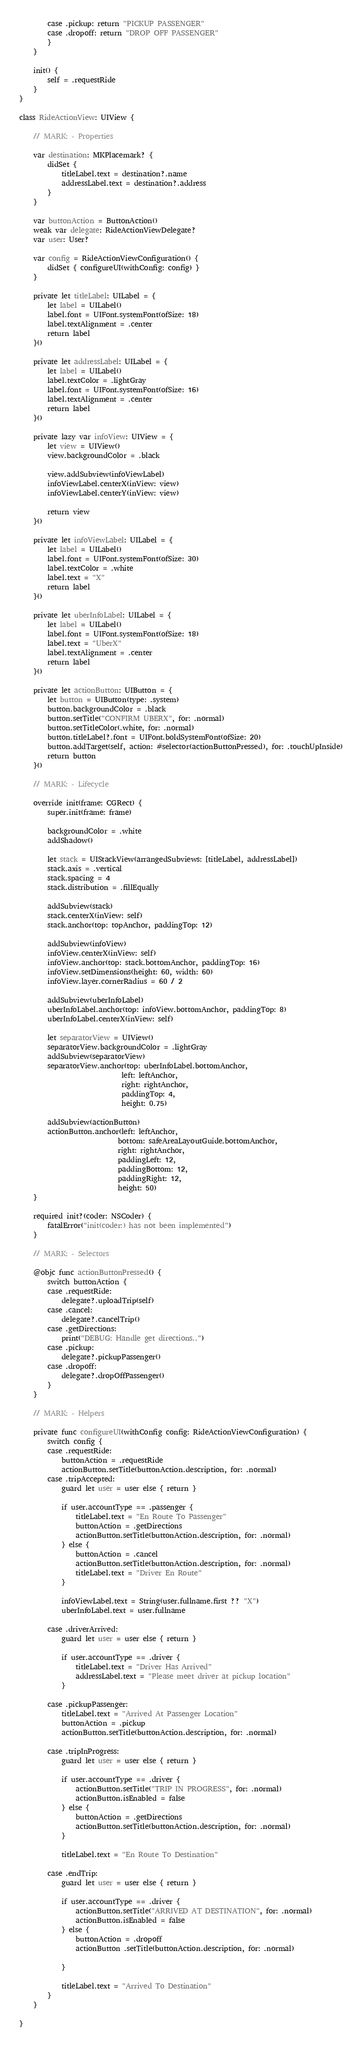<code> <loc_0><loc_0><loc_500><loc_500><_Swift_>        case .pickup: return "PICKUP PASSENGER"
        case .dropoff: return "DROP OFF PASSENGER"
        }
    }
    
    init() {
        self = .requestRide
    }
}

class RideActionView: UIView {

    // MARK: - Properties
    
    var destination: MKPlacemark? {
        didSet {
            titleLabel.text = destination?.name
            addressLabel.text = destination?.address
        }
    }
    
    var buttonAction = ButtonAction()
    weak var delegate: RideActionViewDelegate?
    var user: User?
    
    var config = RideActionViewConfiguration() {
        didSet { configureUI(withConfig: config) }
    }
    
    private let titleLabel: UILabel = {
        let label = UILabel()
        label.font = UIFont.systemFont(ofSize: 18)
        label.textAlignment = .center
        return label
    }()
    
    private let addressLabel: UILabel = {
        let label = UILabel()
        label.textColor = .lightGray
        label.font = UIFont.systemFont(ofSize: 16)
        label.textAlignment = .center
        return label
    }()
    
    private lazy var infoView: UIView = {
        let view = UIView()
        view.backgroundColor = .black
        
        view.addSubview(infoViewLabel)
        infoViewLabel.centerX(inView: view)
        infoViewLabel.centerY(inView: view)
        
        return view
    }()
    
    private let infoViewLabel: UILabel = {
        let label = UILabel()
        label.font = UIFont.systemFont(ofSize: 30)
        label.textColor = .white
        label.text = "X"
        return label
    }()
    
    private let uberInfoLabel: UILabel = {
        let label = UILabel()
        label.font = UIFont.systemFont(ofSize: 18)
        label.text = "UberX"
        label.textAlignment = .center
        return label
    }()
    
    private let actionButton: UIButton = {
        let button = UIButton(type: .system)
        button.backgroundColor = .black
        button.setTitle("CONFIRM UBERX", for: .normal)
        button.setTitleColor(.white, for: .normal)
        button.titleLabel?.font = UIFont.boldSystemFont(ofSize: 20)
        button.addTarget(self, action: #selector(actionButtonPressed), for: .touchUpInside)
        return button
    }()
    
    // MARK: - Lifecycle
    
    override init(frame: CGRect) {
        super.init(frame: frame)
        
        backgroundColor = .white
        addShadow()
    
        let stack = UIStackView(arrangedSubviews: [titleLabel, addressLabel])
        stack.axis = .vertical
        stack.spacing = 4
        stack.distribution = .fillEqually
        
        addSubview(stack)
        stack.centerX(inView: self)
        stack.anchor(top: topAnchor, paddingTop: 12)
        
        addSubview(infoView)
        infoView.centerX(inView: self)
        infoView.anchor(top: stack.bottomAnchor, paddingTop: 16)
        infoView.setDimensions(height: 60, width: 60)
        infoView.layer.cornerRadius = 60 / 2
        
        addSubview(uberInfoLabel)
        uberInfoLabel.anchor(top: infoView.bottomAnchor, paddingTop: 8)
        uberInfoLabel.centerX(inView: self)
        
        let separatorView = UIView()
        separatorView.backgroundColor = .lightGray
        addSubview(separatorView)
        separatorView.anchor(top: uberInfoLabel.bottomAnchor,
                             left: leftAnchor,
                             right: rightAnchor,
                             paddingTop: 4,
                             height: 0.75)
        
        addSubview(actionButton)
        actionButton.anchor(left: leftAnchor,
                            bottom: safeAreaLayoutGuide.bottomAnchor,
                            right: rightAnchor,
                            paddingLeft: 12,
                            paddingBottom: 12,
                            paddingRight: 12,
                            height: 50)
    }
    
    required init?(coder: NSCoder) {
        fatalError("init(coder:) has not been implemented")
    }
    
    // MARK: - Selectors
    
    @objc func actionButtonPressed() {
        switch buttonAction {
        case .requestRide:
            delegate?.uploadTrip(self)
        case .cancel:
            delegate?.cancelTrip()
        case .getDirections:
            print("DEBUG: Handle get directions..")
        case .pickup:
            delegate?.pickupPassenger()
        case .dropoff:
            delegate?.dropOffPassenger()
        }
    }
    
    // MARK: - Helpers
    
    private func configureUI(withConfig config: RideActionViewConfiguration) {
        switch config {
        case .requestRide:
            buttonAction = .requestRide
            actionButton.setTitle(buttonAction.description, for: .normal)
        case .tripAccepted:
            guard let user = user else { return }
            
            if user.accountType == .passenger {
                titleLabel.text = "En Route To Passenger"
                buttonAction = .getDirections
                actionButton.setTitle(buttonAction.description, for: .normal)
            } else {
                buttonAction = .cancel
                actionButton.setTitle(buttonAction.description, for: .normal)
                titleLabel.text = "Driver En Route"
            }
            
            infoViewLabel.text = String(user.fullname.first ?? "X")
            uberInfoLabel.text = user.fullname
            
        case .driverArrived:
            guard let user = user else { return }
            
            if user.accountType == .driver {
                titleLabel.text = "Driver Has Arrived"
                addressLabel.text = "Please meet driver at pickup location"
            }
            
        case .pickupPassenger:
            titleLabel.text = "Arrived At Passenger Location"
            buttonAction = .pickup
            actionButton.setTitle(buttonAction.description, for: .normal)
            
        case .tripInProgress:
            guard let user = user else { return }
            
            if user.accountType == .driver {
                actionButton.setTitle("TRIP IN PROGRESS", for: .normal)
                actionButton.isEnabled = false
            } else {
                buttonAction = .getDirections
                actionButton.setTitle(buttonAction.description, for: .normal)
            }
            
            titleLabel.text = "En Route To Destination"
            
        case .endTrip:
            guard let user = user else { return }
            
            if user.accountType == .driver {
                actionButton.setTitle("ARRIVED AT DESTINATION", for: .normal)
                actionButton.isEnabled = false
            } else {
                buttonAction = .dropoff
                actionButton .setTitle(buttonAction.description, for: .normal)
                
            }
            
            titleLabel.text = "Arrived To Destination"
        }
    }
    
}
</code> 